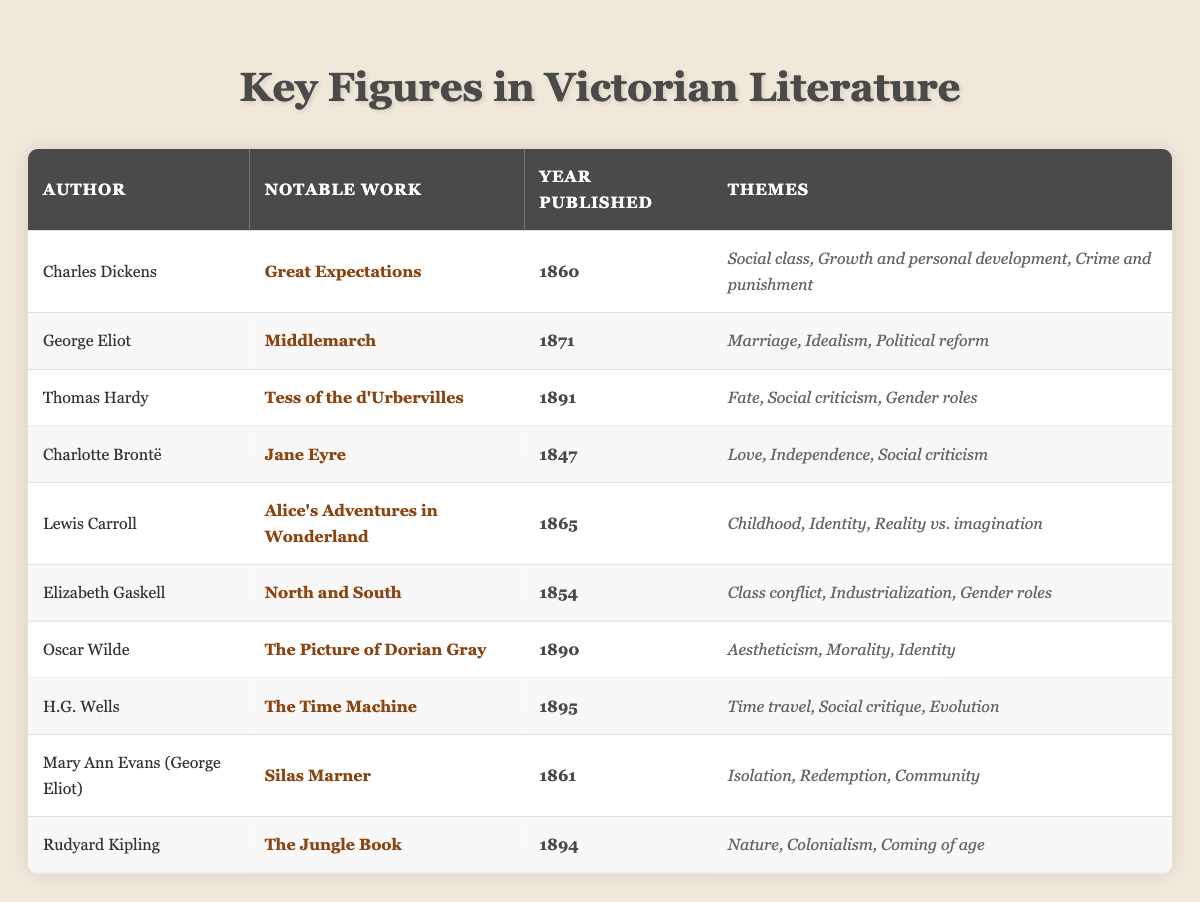What is the year of publication for "Jane Eyre"? Looking at the table, the row for "Jane Eyre" lists the year published as 1847.
Answer: 1847 Which author wrote "The Jungle Book"? The table indicates that "The Jungle Book" is the notable work of Rudyard Kipling.
Answer: Rudyard Kipling What are the themes of "Great Expectations"? The themes listed for "Great Expectations" in the table are social class, growth and personal development, and crime and punishment.
Answer: Social class, growth and personal development, crime and punishment Which author published their notable work in 1895? Scanning the table, H.G. Wells is the author who published "The Time Machine" in 1895.
Answer: H.G. Wells Is "Middlemarch" published before "The Picture of Dorian Gray"? Since "Middlemarch" was published in 1871 and "The Picture of Dorian Gray" in 1890, it is true that "Middlemarch" was published earlier.
Answer: Yes Which two works focus on social criticism? Referring to the table, both "Tess of the d'Urbervilles" by Thomas Hardy and "The Picture of Dorian Gray" by Oscar Wilde address social criticism.
Answer: Tess of the d'Urbervilles and The Picture of Dorian Gray What is the earliest published work listed in the table? The rows are scanned for publication years; "Jane Eyre" is published in 1847, which is the earliest date in the table.
Answer: Jane Eyre How many authors in the table wrote works that include themes related to gender roles? By reviewing the themes, "Tess of the d'Urbervilles," "North and South," and "The Jungle Book" all address gender roles, contributing to a count of three authors.
Answer: 3 What notable work was published in 1894? Checking the table, "The Jungle Book" by Rudyard Kipling is noted as published in 1894.
Answer: The Jungle Book If you list all the themes from the works published before 1870, how many unique themes can you identify? The themes before 1870 from the table are: "Love," "Independence," "Class conflict," "Childhood," "Social criticism," "Marriage," "Idealism," and "Isolation." From these, there are seven unique themes.
Answer: 7 Which author has the most thematic diversity in their work among the listings? Considering the themes provided, Oscar Wilde's "The Picture of Dorian Gray" includes aestheticism, morality, and identity, which appear quite broad, alongside others like Hardy and Eliot, suggesting Wilde may have the most diversity.
Answer: Oscar Wilde 